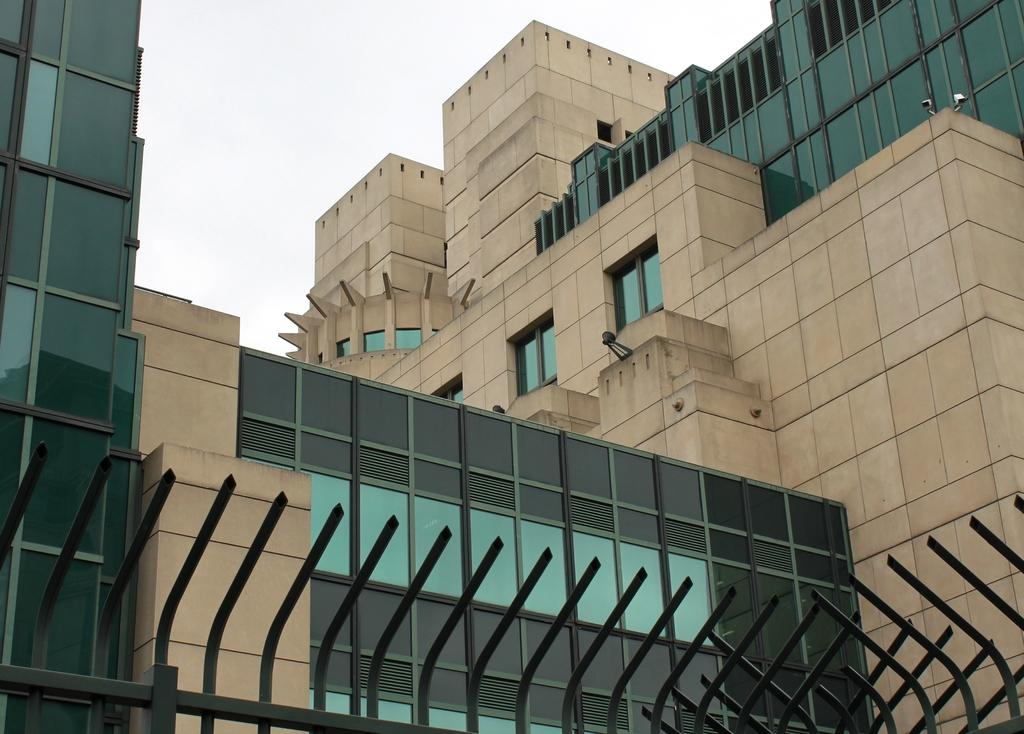What type of structure is visible in the image? There is a building with windows in the image. What can be seen in the background of the image? The sky is visible in the image. What objects are present in the foreground of the image? There are metal poles in the foreground of the image. Are there any poisonous plants growing near the metal poles in the image? There is no mention of plants, poisonous or otherwise, in the image. 